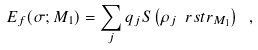<formula> <loc_0><loc_0><loc_500><loc_500>E _ { f } ( \sigma ; M _ { 1 } ) = \sum _ { j } q _ { j } S \left ( \rho _ { j } \ r s t r _ { M _ { 1 } } \right ) \ ,</formula> 